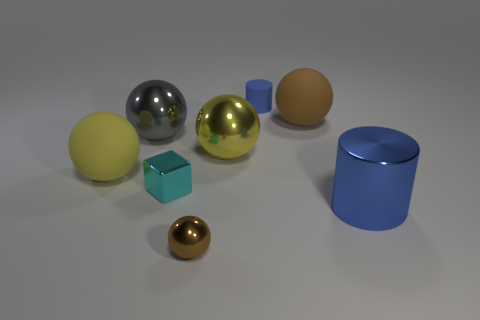How many brown balls must be subtracted to get 1 brown balls? 1 Subtract all large spheres. How many spheres are left? 1 Add 1 big blue matte blocks. How many objects exist? 9 Subtract all big blue shiny things. Subtract all tiny brown shiny objects. How many objects are left? 6 Add 7 gray spheres. How many gray spheres are left? 8 Add 1 red cylinders. How many red cylinders exist? 1 Subtract all brown balls. How many balls are left? 3 Subtract 0 cyan cylinders. How many objects are left? 8 Subtract all balls. How many objects are left? 3 Subtract 1 blocks. How many blocks are left? 0 